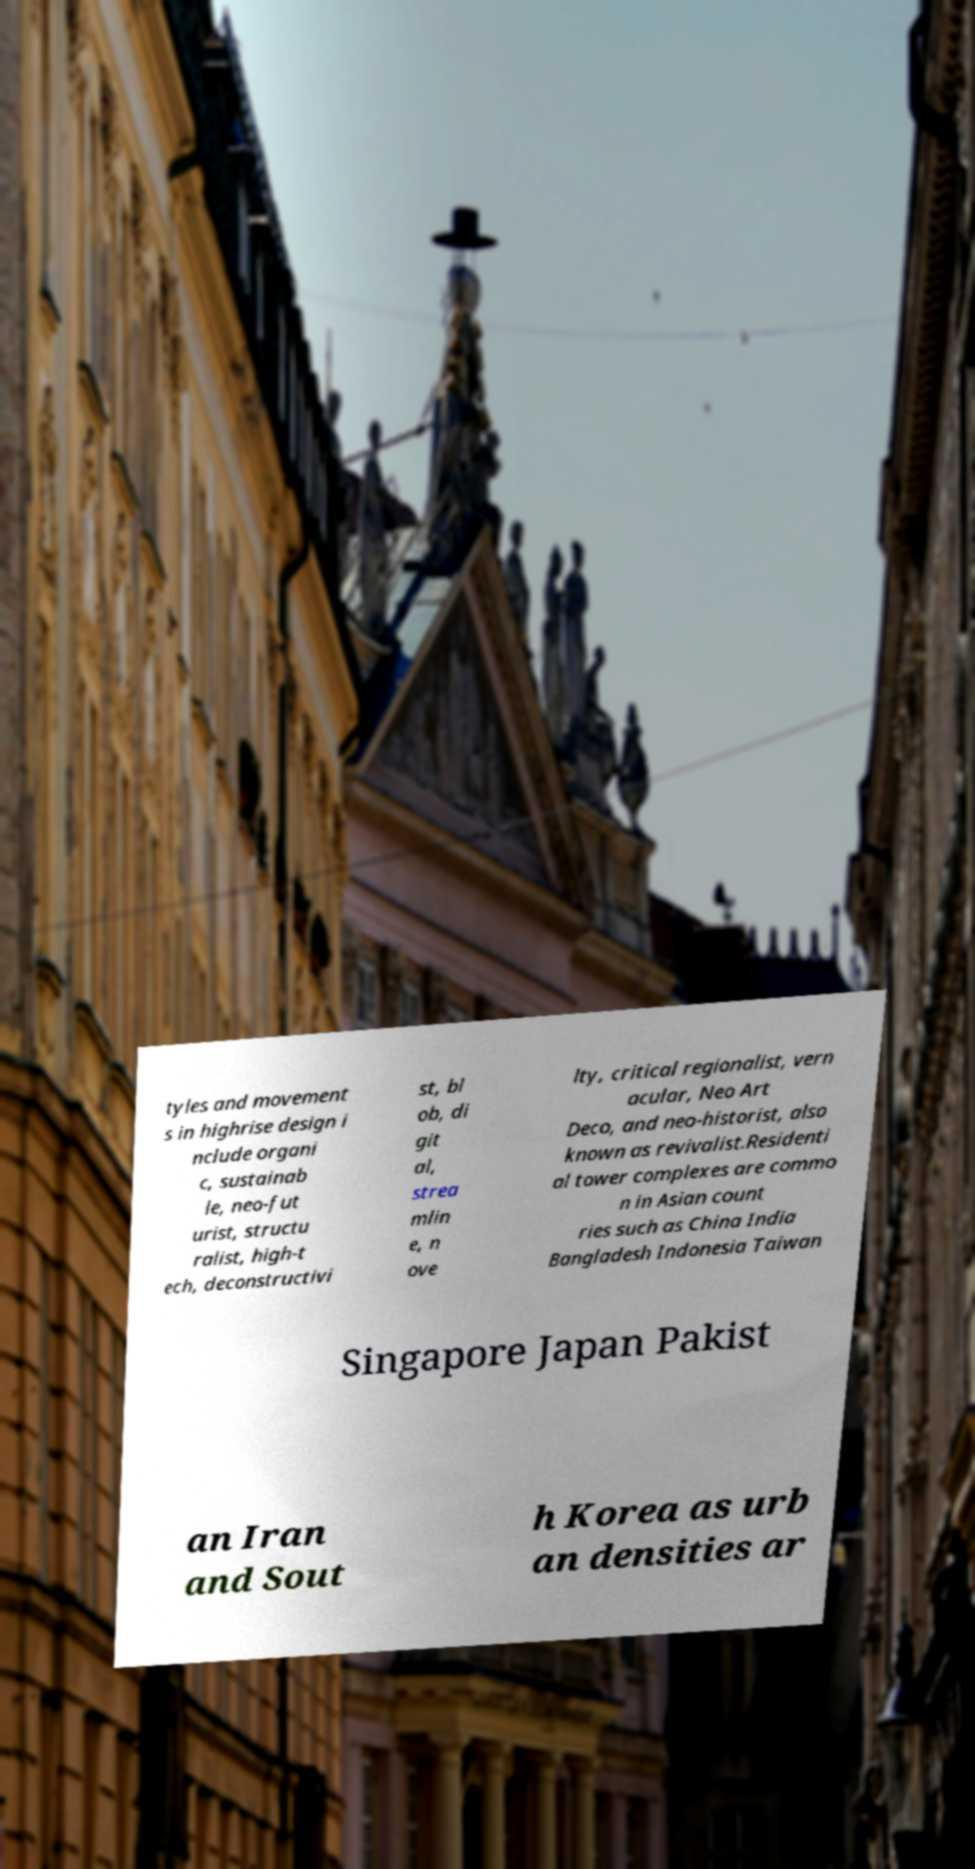Can you accurately transcribe the text from the provided image for me? tyles and movement s in highrise design i nclude organi c, sustainab le, neo-fut urist, structu ralist, high-t ech, deconstructivi st, bl ob, di git al, strea mlin e, n ove lty, critical regionalist, vern acular, Neo Art Deco, and neo-historist, also known as revivalist.Residenti al tower complexes are commo n in Asian count ries such as China India Bangladesh Indonesia Taiwan Singapore Japan Pakist an Iran and Sout h Korea as urb an densities ar 